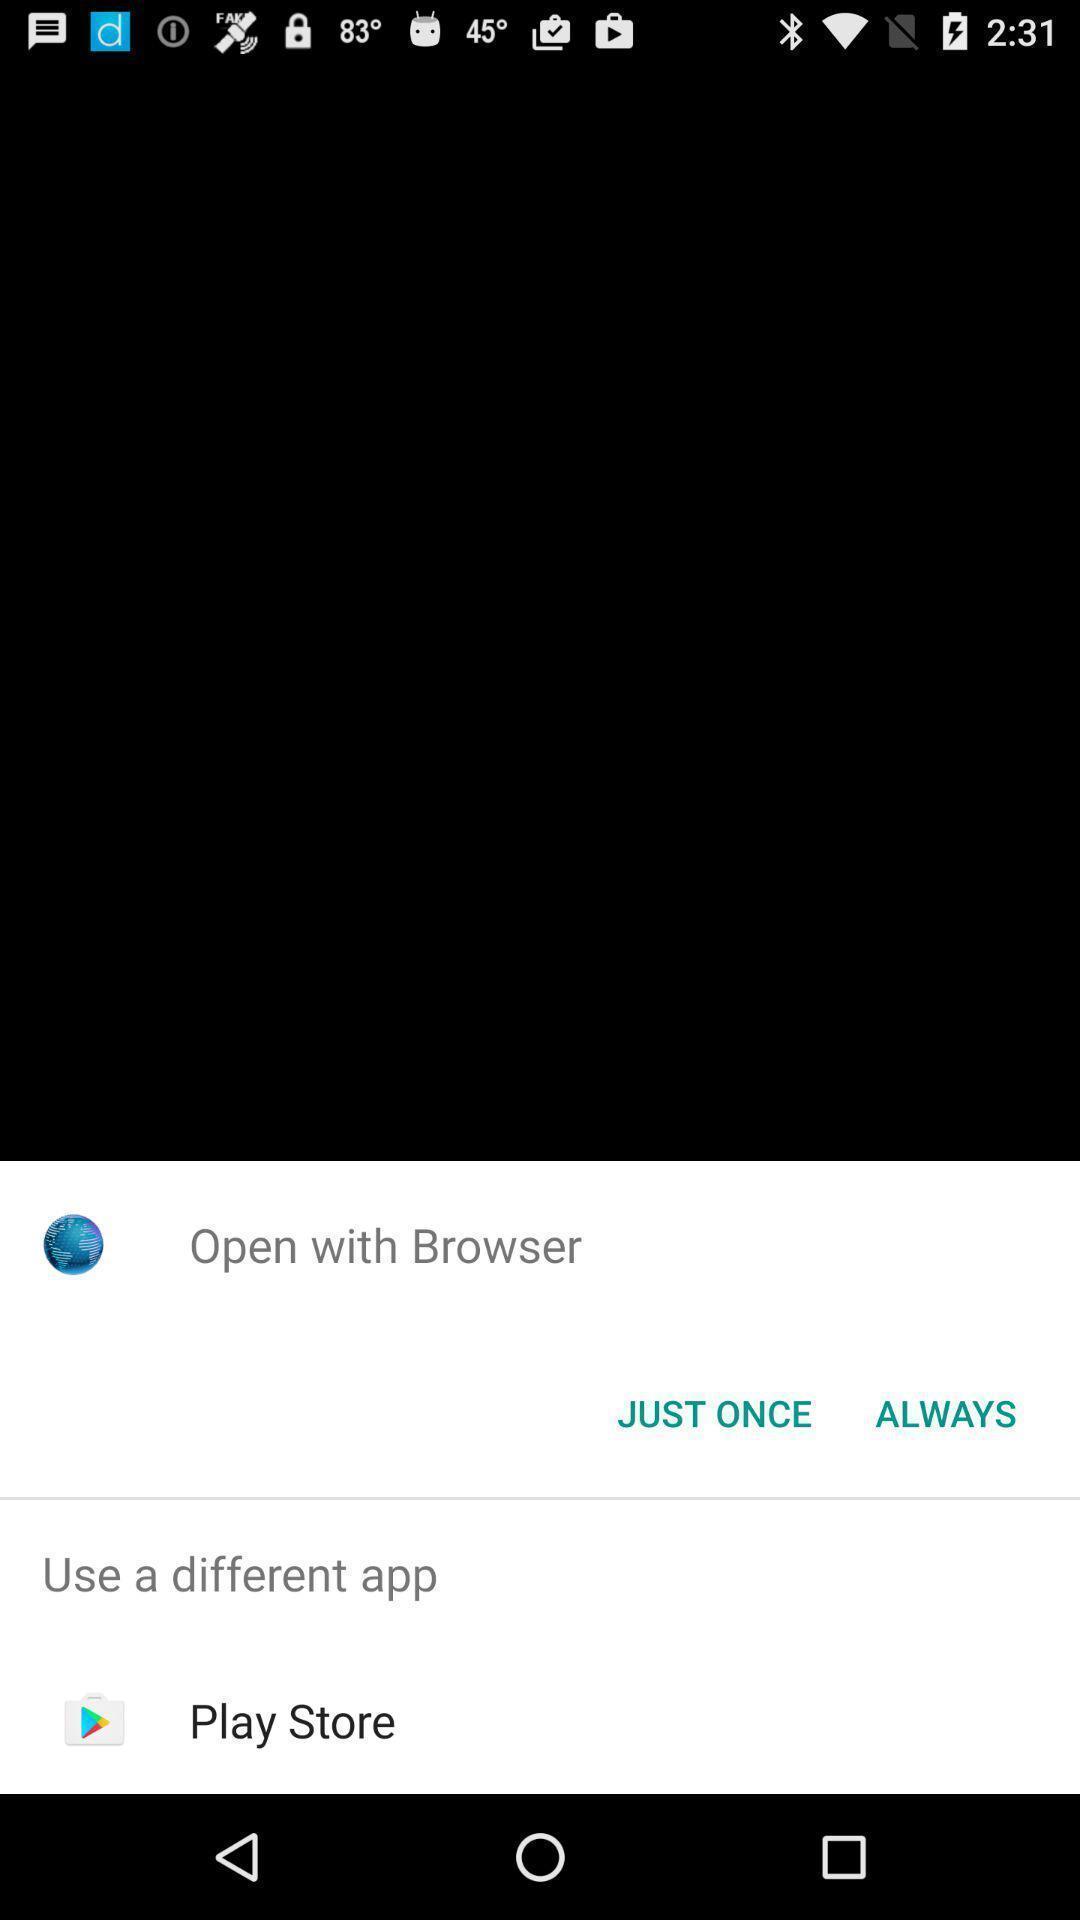Give me a summary of this screen capture. Pop up showing use a different application. 